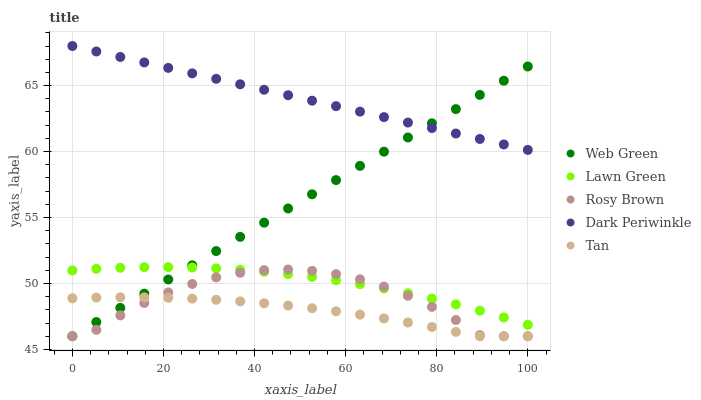Does Tan have the minimum area under the curve?
Answer yes or no. Yes. Does Dark Periwinkle have the maximum area under the curve?
Answer yes or no. Yes. Does Rosy Brown have the minimum area under the curve?
Answer yes or no. No. Does Rosy Brown have the maximum area under the curve?
Answer yes or no. No. Is Web Green the smoothest?
Answer yes or no. Yes. Is Rosy Brown the roughest?
Answer yes or no. Yes. Is Tan the smoothest?
Answer yes or no. No. Is Tan the roughest?
Answer yes or no. No. Does Tan have the lowest value?
Answer yes or no. Yes. Does Dark Periwinkle have the lowest value?
Answer yes or no. No. Does Dark Periwinkle have the highest value?
Answer yes or no. Yes. Does Rosy Brown have the highest value?
Answer yes or no. No. Is Lawn Green less than Dark Periwinkle?
Answer yes or no. Yes. Is Dark Periwinkle greater than Tan?
Answer yes or no. Yes. Does Web Green intersect Lawn Green?
Answer yes or no. Yes. Is Web Green less than Lawn Green?
Answer yes or no. No. Is Web Green greater than Lawn Green?
Answer yes or no. No. Does Lawn Green intersect Dark Periwinkle?
Answer yes or no. No. 